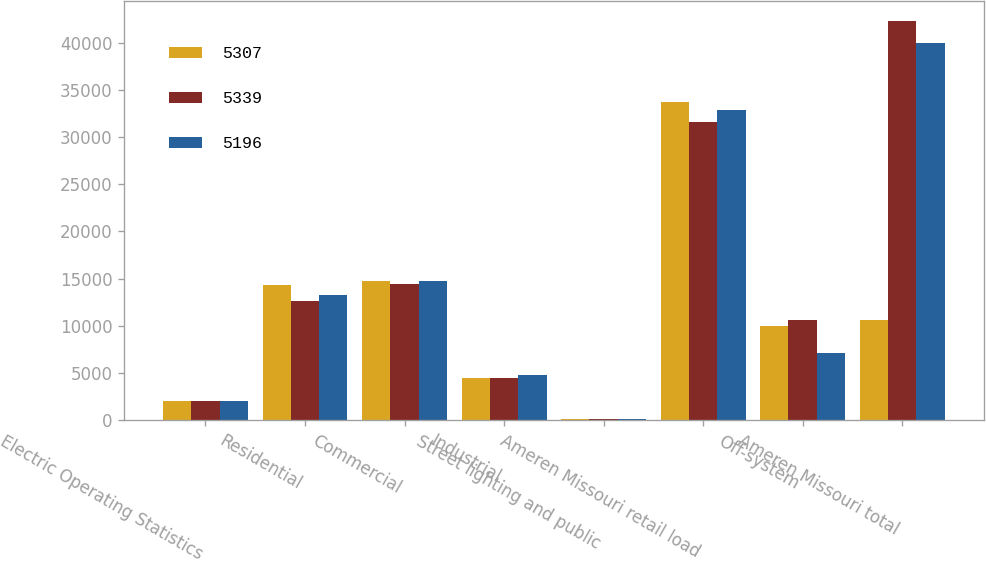<chart> <loc_0><loc_0><loc_500><loc_500><stacked_bar_chart><ecel><fcel>Electric Operating Statistics<fcel>Residential<fcel>Commercial<fcel>Industrial<fcel>Street lighting and public<fcel>Ameren Missouri retail load<fcel>Off-system<fcel>Ameren Missouri total<nl><fcel>5307<fcel>2018<fcel>14320<fcel>14791<fcel>4499<fcel>108<fcel>33718<fcel>10036<fcel>10640<nl><fcel>5339<fcel>2017<fcel>12653<fcel>14384<fcel>4469<fcel>117<fcel>31623<fcel>10640<fcel>42263<nl><fcel>5196<fcel>2016<fcel>13245<fcel>14712<fcel>4790<fcel>125<fcel>32872<fcel>7125<fcel>39997<nl></chart> 